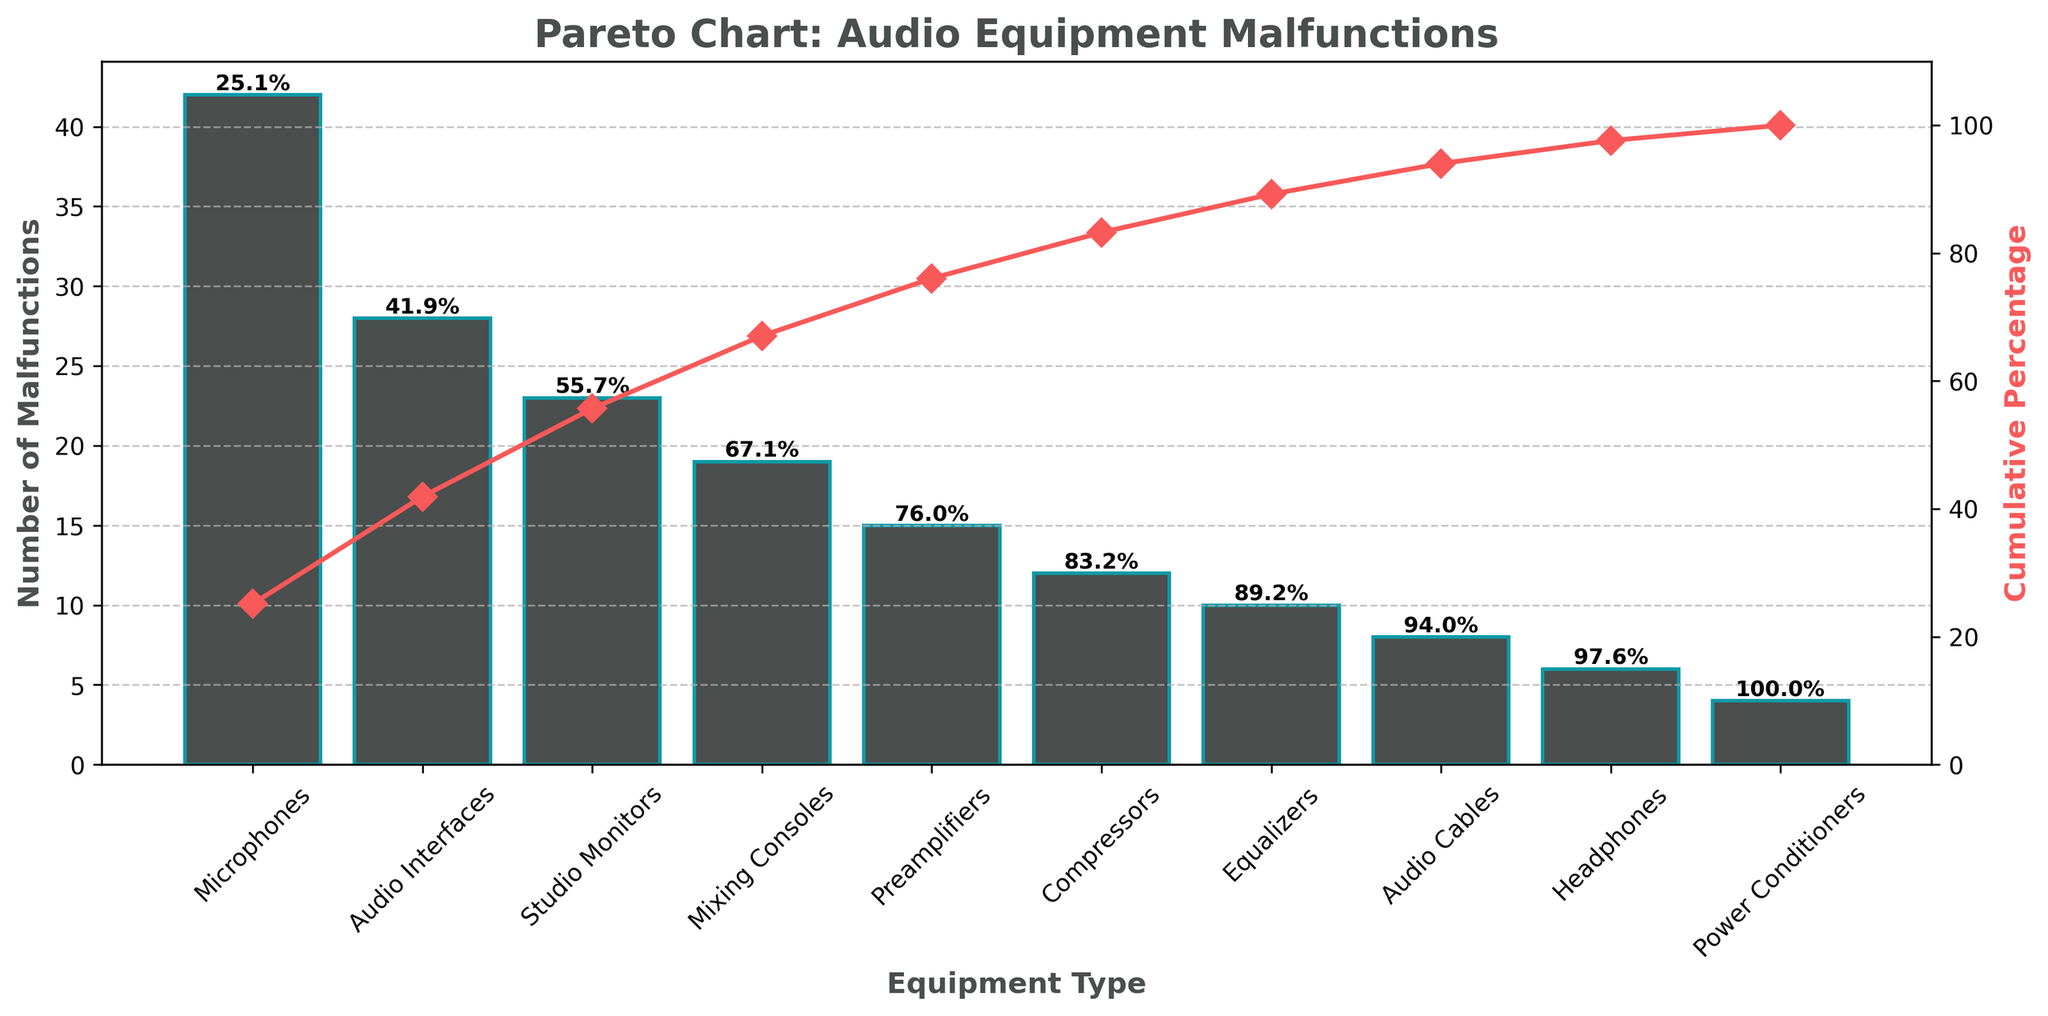What's the title of the figure? The title is displayed at the top of the chart and introduces the main topic of the visualization. It reads "Pareto Chart: Audio Equipment Malfunctions."
Answer: Pareto Chart: Audio Equipment Malfunctions What's the cumulative percentage after the four types of equipment with the most malfunctions? We need to add the cumulative percentages of the first four equipment types (Microphones, Audio Interfaces, Studio Monitors, and Mixing Consoles). According to the chart, they are approximately: 32.4%, 54.6%, 72.4%, and 86.8%. Adding these percentages, the cumulative percentage after the four types is about 86.8%.
Answer: 86.8% Which type of equipment has the second-highest number of malfunctions? The bar chart shows the number of malfunctions for each equipment type. The second-highest bar represents Audio Interfaces.
Answer: Audio Interfaces How many malfunctions are reported for Studio Monitors and Mixing Consoles combined? We need to add the number of malfunctions for both equipment types: 23 (Studio Monitors) + 19 (Mixing Consoles) = 42 malfunctions combined.
Answer: 42 What's the cumulative percentage line color in the chart? The cumulative percentage line is marked in the figure with a distinct color in contrast to the bar colors. It is represented with a red line.
Answer: Red Which equipment type is responsible for the smallest number of malfunctions? The shortest bar in the chart corresponds to the equipment type with the fewest malfunctions. This is Power Conditioners.
Answer: Power Conditioners What's the cumulative percentage after compressors? We first find the cumulative percentage for Compressors by looking at the line markers. From left to right, compressors (12 incidents) follow Preamplifiers (with 15 malfunctions). According to the plot, Compressors lie at the cumulative percentage of 85.9%.
Answer: 85.9% What portion of total malfunctions does the top three types of equipment contribute to? We sum the number of malfunctions for the top three equipment types: Microphones (42), Audio Interfaces (28), and Studio Monitors (23). The total malfunctions in these three categories are 42 + 28 + 23 = 93. To find the portion of the total, we also add all malfunctions: 42+28+23+19+15+12+10+8+6+4=167. Then (93/167) * 100 ≈ 55.7%.
Answer: 55.7% What does the dashed line and the grid represent in the chart? The dashed line and grid indicate the y-axis reference lines, providing a visual aid for interpreting data points along the y-axis, particularly the number of malfunctions.
Answer: Y-axis reference lines and number of malfunctions How many equipment types have fewer than 20 malfunctions? To find this, count the bars with heights less than 20: Preamplifiers (15), Compressors (12), Equalizers (10), Audio Cables (8), Headphones (6), and Power Conditioners (4). This totals 6 equipment types.
Answer: 6 